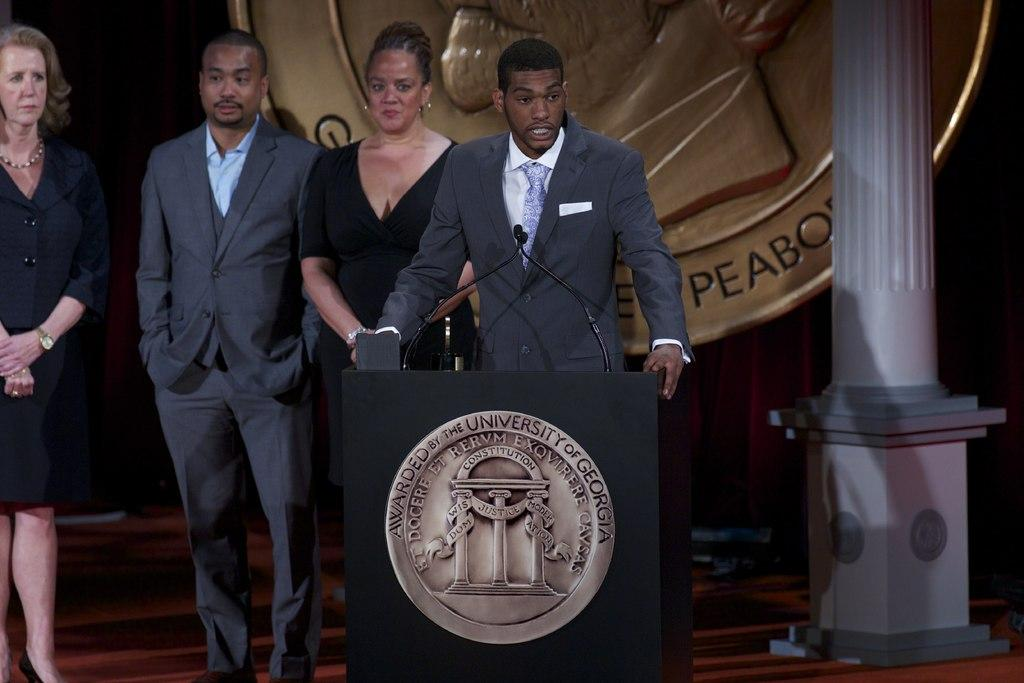<image>
Present a compact description of the photo's key features. people standing behind a podium that has a medal on it that says 'awarded by the university of georgia' 